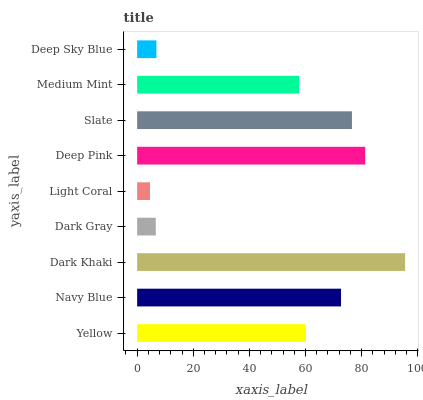Is Light Coral the minimum?
Answer yes or no. Yes. Is Dark Khaki the maximum?
Answer yes or no. Yes. Is Navy Blue the minimum?
Answer yes or no. No. Is Navy Blue the maximum?
Answer yes or no. No. Is Navy Blue greater than Yellow?
Answer yes or no. Yes. Is Yellow less than Navy Blue?
Answer yes or no. Yes. Is Yellow greater than Navy Blue?
Answer yes or no. No. Is Navy Blue less than Yellow?
Answer yes or no. No. Is Yellow the high median?
Answer yes or no. Yes. Is Yellow the low median?
Answer yes or no. Yes. Is Dark Khaki the high median?
Answer yes or no. No. Is Dark Gray the low median?
Answer yes or no. No. 